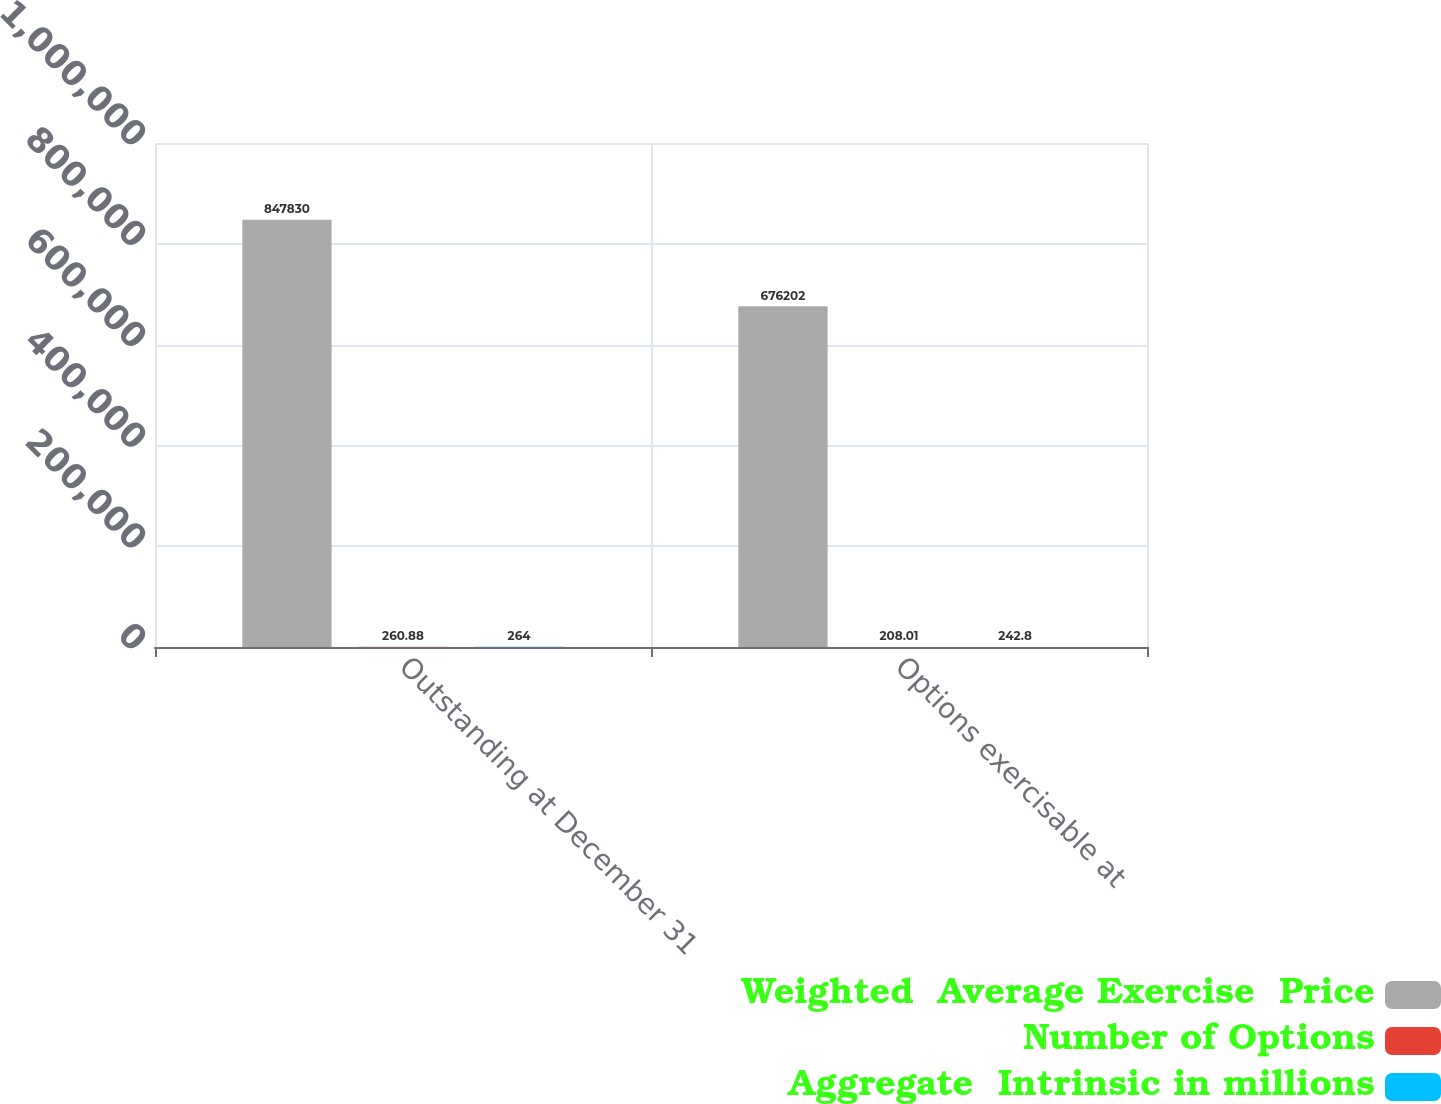Convert chart to OTSL. <chart><loc_0><loc_0><loc_500><loc_500><stacked_bar_chart><ecel><fcel>Outstanding at December 31<fcel>Options exercisable at<nl><fcel>Weighted  Average Exercise  Price<fcel>847830<fcel>676202<nl><fcel>Number of Options<fcel>260.88<fcel>208.01<nl><fcel>Aggregate  Intrinsic in millions<fcel>264<fcel>242.8<nl></chart> 